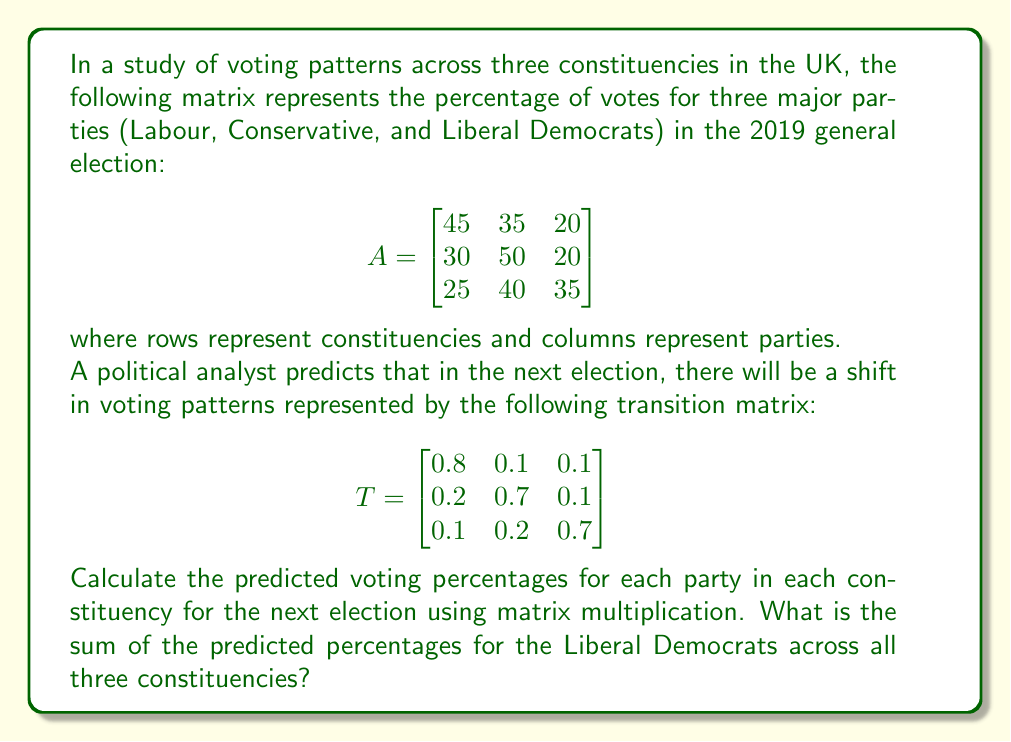What is the answer to this math problem? To solve this problem, we need to perform matrix multiplication between the original voting pattern matrix A and the transition matrix T. This will give us the predicted voting percentages for the next election.

Let's call the resulting matrix B. We can calculate B as follows:

$$B = A \times T$$

Performing the matrix multiplication:

$$\begin{align}
B &= \begin{bmatrix}
45 & 35 & 20 \\
30 & 50 & 20 \\
25 & 40 & 35
\end{bmatrix} \times 
\begin{bmatrix}
0.8 & 0.1 & 0.1 \\
0.2 & 0.7 & 0.1 \\
0.1 & 0.2 & 0.7
\end{bmatrix} \\[10pt]
&= \begin{bmatrix}
(45 \times 0.8 + 35 \times 0.2 + 20 \times 0.1) & (45 \times 0.1 + 35 \times 0.7 + 20 \times 0.2) & (45 \times 0.1 + 35 \times 0.1 + 20 \times 0.7) \\
(30 \times 0.8 + 50 \times 0.2 + 20 \times 0.1) & (30 \times 0.1 + 50 \times 0.7 + 20 \times 0.2) & (30 \times 0.1 + 50 \times 0.1 + 20 \times 0.7) \\
(25 \times 0.8 + 40 \times 0.2 + 35 \times 0.1) & (25 \times 0.1 + 40 \times 0.7 + 35 \times 0.2) & (25 \times 0.1 + 40 \times 0.1 + 35 \times 0.7)
\end{bmatrix} \\[10pt]
&= \begin{bmatrix}
43 & 30.5 & 26.5 \\
34 & 41 & 25 \\
30 & 37 & 33
\end{bmatrix}
\end{align}$$

Now, we have the predicted voting percentages for each party in each constituency. To find the sum of the predicted percentages for the Liberal Democrats across all three constituencies, we need to sum the values in the third column of matrix B:

$26.5 + 25 + 33 = 84.5$
Answer: 84.5% 